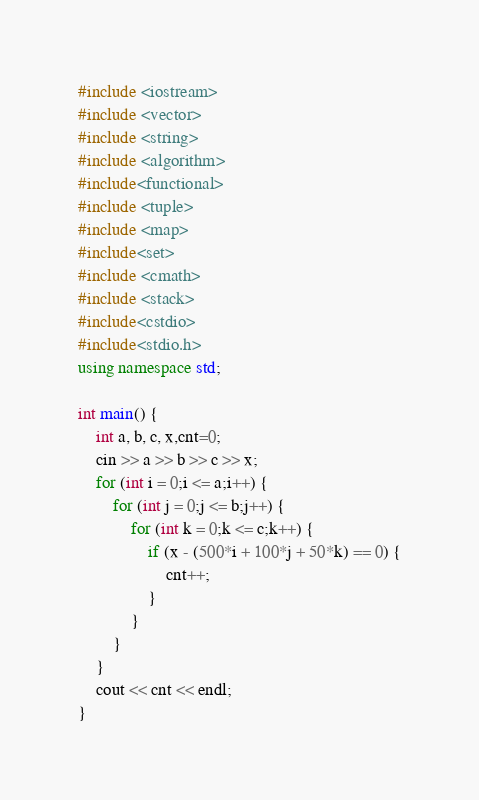<code> <loc_0><loc_0><loc_500><loc_500><_C++_>#include <iostream>
#include <vector>
#include <string>
#include <algorithm>
#include<functional>
#include <tuple>
#include <map>
#include<set>
#include <cmath>
#include <stack>
#include<cstdio>
#include<stdio.h>
using namespace std;

int main() {
	int a, b, c, x,cnt=0;
	cin >> a >> b >> c >> x;
	for (int i = 0;i <= a;i++) {
		for (int j = 0;j <= b;j++) {
			for (int k = 0;k <= c;k++) {
				if (x - (500*i + 100*j + 50*k) == 0) {
					cnt++;
				}
			}
		}
	}
	cout << cnt << endl;
}</code> 